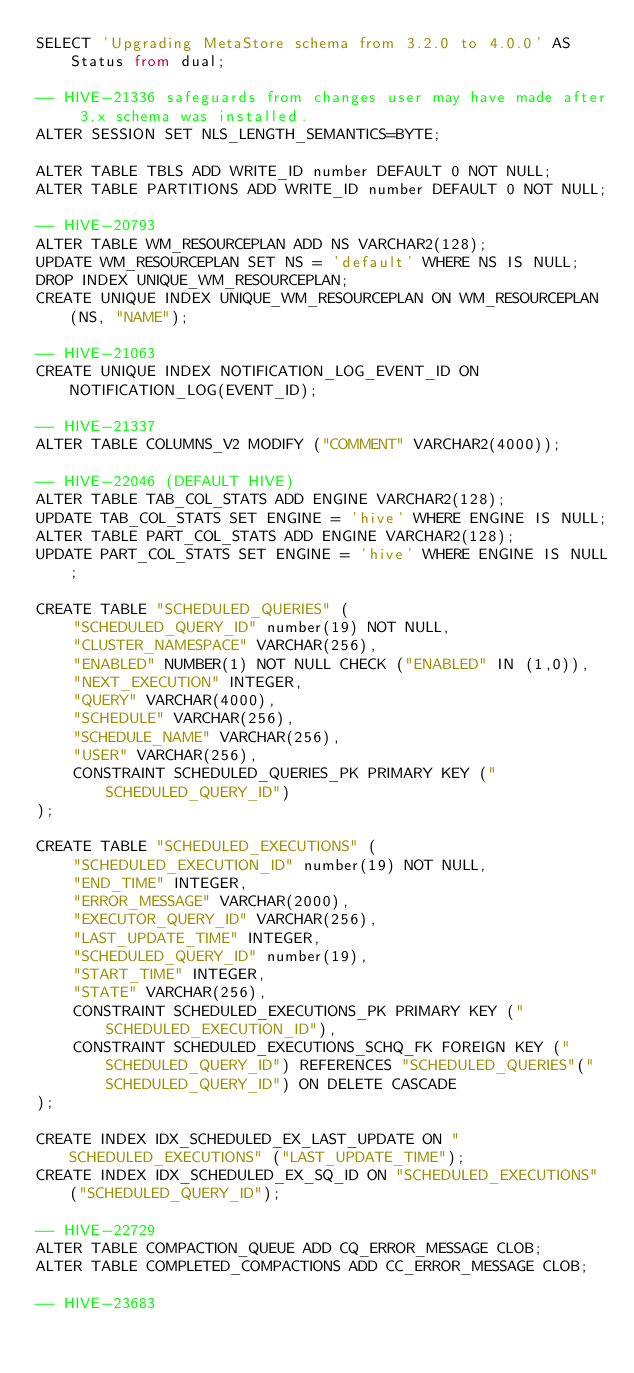<code> <loc_0><loc_0><loc_500><loc_500><_SQL_>SELECT 'Upgrading MetaStore schema from 3.2.0 to 4.0.0' AS Status from dual;

-- HIVE-21336 safeguards from changes user may have made after 3.x schema was installed.
ALTER SESSION SET NLS_LENGTH_SEMANTICS=BYTE;

ALTER TABLE TBLS ADD WRITE_ID number DEFAULT 0 NOT NULL;
ALTER TABLE PARTITIONS ADD WRITE_ID number DEFAULT 0 NOT NULL;

-- HIVE-20793
ALTER TABLE WM_RESOURCEPLAN ADD NS VARCHAR2(128);
UPDATE WM_RESOURCEPLAN SET NS = 'default' WHERE NS IS NULL;
DROP INDEX UNIQUE_WM_RESOURCEPLAN;
CREATE UNIQUE INDEX UNIQUE_WM_RESOURCEPLAN ON WM_RESOURCEPLAN (NS, "NAME");

-- HIVE-21063
CREATE UNIQUE INDEX NOTIFICATION_LOG_EVENT_ID ON NOTIFICATION_LOG(EVENT_ID);

-- HIVE-21337
ALTER TABLE COLUMNS_V2 MODIFY ("COMMENT" VARCHAR2(4000));

-- HIVE-22046 (DEFAULT HIVE)
ALTER TABLE TAB_COL_STATS ADD ENGINE VARCHAR2(128);
UPDATE TAB_COL_STATS SET ENGINE = 'hive' WHERE ENGINE IS NULL;
ALTER TABLE PART_COL_STATS ADD ENGINE VARCHAR2(128);
UPDATE PART_COL_STATS SET ENGINE = 'hive' WHERE ENGINE IS NULL;

CREATE TABLE "SCHEDULED_QUERIES" (
	"SCHEDULED_QUERY_ID" number(19) NOT NULL,
	"CLUSTER_NAMESPACE" VARCHAR(256),
	"ENABLED" NUMBER(1) NOT NULL CHECK ("ENABLED" IN (1,0)),
	"NEXT_EXECUTION" INTEGER,
	"QUERY" VARCHAR(4000),
	"SCHEDULE" VARCHAR(256),
	"SCHEDULE_NAME" VARCHAR(256),
	"USER" VARCHAR(256),
	CONSTRAINT SCHEDULED_QUERIES_PK PRIMARY KEY ("SCHEDULED_QUERY_ID")
);

CREATE TABLE "SCHEDULED_EXECUTIONS" (
	"SCHEDULED_EXECUTION_ID" number(19) NOT NULL,
	"END_TIME" INTEGER,
	"ERROR_MESSAGE" VARCHAR(2000),
	"EXECUTOR_QUERY_ID" VARCHAR(256),
	"LAST_UPDATE_TIME" INTEGER,
	"SCHEDULED_QUERY_ID" number(19),
	"START_TIME" INTEGER,
	"STATE" VARCHAR(256),
	CONSTRAINT SCHEDULED_EXECUTIONS_PK PRIMARY KEY ("SCHEDULED_EXECUTION_ID"),
	CONSTRAINT SCHEDULED_EXECUTIONS_SCHQ_FK FOREIGN KEY ("SCHEDULED_QUERY_ID") REFERENCES "SCHEDULED_QUERIES"("SCHEDULED_QUERY_ID") ON DELETE CASCADE
);

CREATE INDEX IDX_SCHEDULED_EX_LAST_UPDATE ON "SCHEDULED_EXECUTIONS" ("LAST_UPDATE_TIME");
CREATE INDEX IDX_SCHEDULED_EX_SQ_ID ON "SCHEDULED_EXECUTIONS" ("SCHEDULED_QUERY_ID");

-- HIVE-22729
ALTER TABLE COMPACTION_QUEUE ADD CQ_ERROR_MESSAGE CLOB;
ALTER TABLE COMPLETED_COMPACTIONS ADD CC_ERROR_MESSAGE CLOB;

-- HIVE-23683</code> 